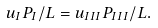Convert formula to latex. <formula><loc_0><loc_0><loc_500><loc_500>u _ { I } P _ { I } / L = u _ { I I I } P _ { I I I } / L .</formula> 